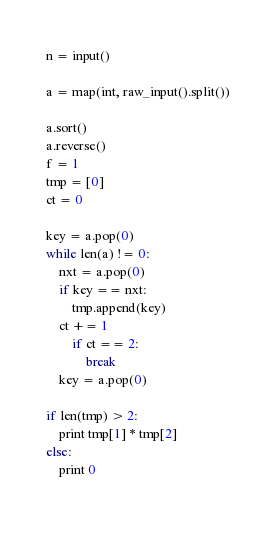Convert code to text. <code><loc_0><loc_0><loc_500><loc_500><_Python_>n = input()

a = map(int, raw_input().split())

a.sort()
a.reverse()
f = 1
tmp = [0]
ct = 0

key = a.pop(0)
while len(a) != 0:
    nxt = a.pop(0)
    if key == nxt:
        tmp.append(key)
	ct += 1
        if ct == 2:
            break
    key = a.pop(0)

if len(tmp) > 2:
    print tmp[1] * tmp[2]
else:
    print 0
    </code> 